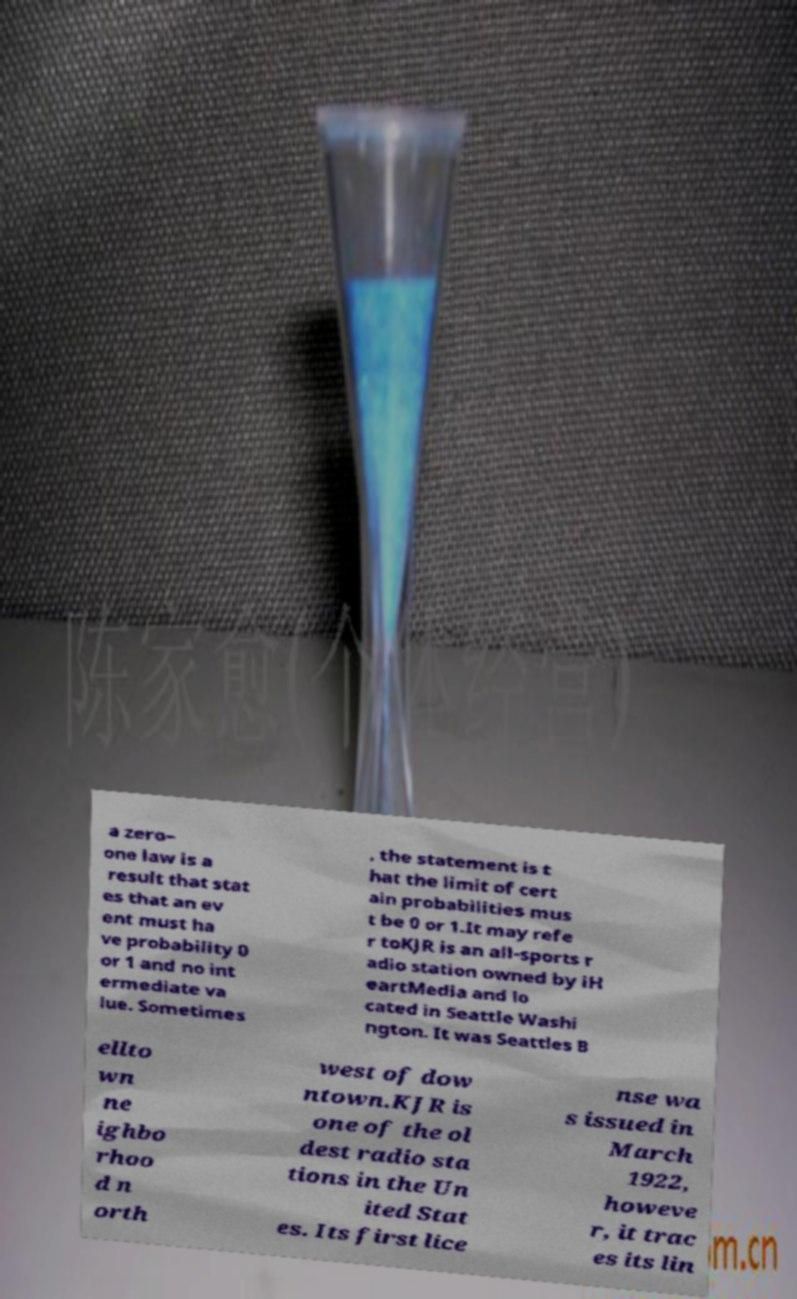Please read and relay the text visible in this image. What does it say? a zero– one law is a result that stat es that an ev ent must ha ve probability 0 or 1 and no int ermediate va lue. Sometimes , the statement is t hat the limit of cert ain probabilities mus t be 0 or 1.It may refe r toKJR is an all-sports r adio station owned by iH eartMedia and lo cated in Seattle Washi ngton. It was Seattles B ellto wn ne ighbo rhoo d n orth west of dow ntown.KJR is one of the ol dest radio sta tions in the Un ited Stat es. Its first lice nse wa s issued in March 1922, howeve r, it trac es its lin 